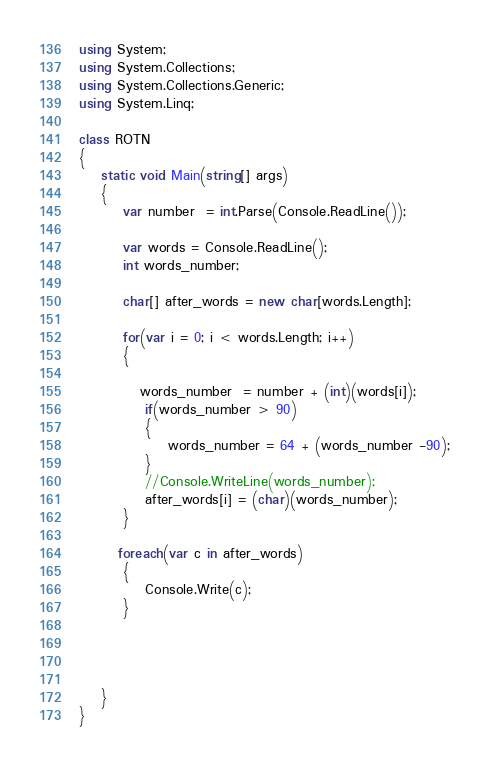<code> <loc_0><loc_0><loc_500><loc_500><_C#_>using System;
using System.Collections;
using System.Collections.Generic;
using System.Linq;

class ROTN
{
    static void Main(string[] args)
    {
        var number  = int.Parse(Console.ReadLine());

        var words = Console.ReadLine();
        int words_number;

        char[] after_words = new char[words.Length];

        for(var i = 0; i < words.Length; i++)
        {
            
           words_number  = number + (int)(words[i]);
            if(words_number > 90)
            {
                words_number = 64 + (words_number -90);
            }
            //Console.WriteLine(words_number);
            after_words[i] = (char)(words_number);
        }

       foreach(var c in after_words)
        {
            Console.Write(c);
        }



      
    }
}</code> 